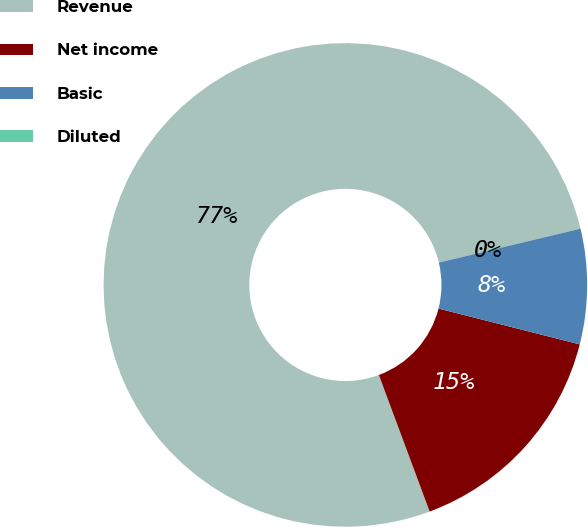Convert chart to OTSL. <chart><loc_0><loc_0><loc_500><loc_500><pie_chart><fcel>Revenue<fcel>Net income<fcel>Basic<fcel>Diluted<nl><fcel>76.92%<fcel>15.38%<fcel>7.69%<fcel>0.0%<nl></chart> 